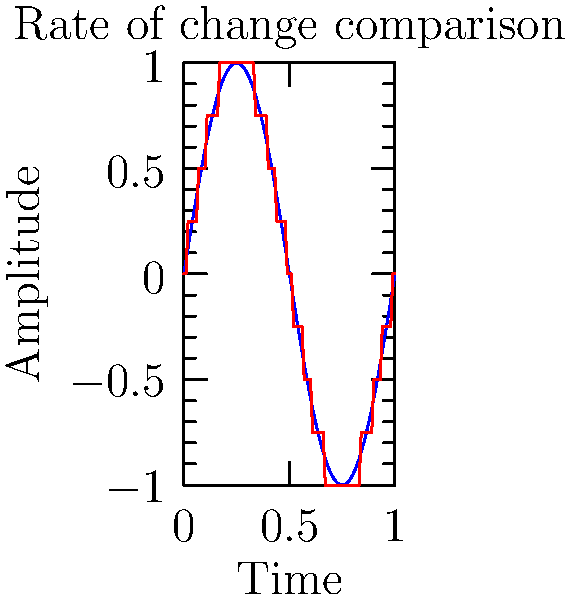Consider the graph showing analog and digital representations of a sound wave. Calculate the difference between the maximum rates of change (slopes) for the analog and digital waveforms. Assume the analog wave is given by $y = \sin(2\pi x)$ and the digital wave is a 4-bit quantized version of the analog wave. To solve this problem, we'll follow these steps:

1) For the analog wave $y = \sin(2\pi x)$:
   The rate of change is given by the derivative: $\frac{dy}{dx} = 2\pi \cos(2\pi x)$
   The maximum rate of change occurs when $\cos(2\pi x) = \pm 1$, so:
   $\left|\frac{dy}{dx}\right|_{max} = 2\pi \approx 6.28$

2) For the digital wave:
   The 4-bit quantization means there are $2^4 = 16$ possible amplitude levels.
   The wave changes by 1 level over 1/8 of the period (as seen in the graph).
   Period of $\sin(2\pi x)$ is 1, so the time for this change is $1/8$.
   Maximum rate of change = $\frac{2/16}{1/8} = 1$

3) The difference between the maximum rates of change:
   $2\pi - 1 \approx 5.28$
Answer: $2\pi - 1 \approx 5.28$ 